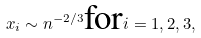Convert formula to latex. <formula><loc_0><loc_0><loc_500><loc_500>x _ { i } \sim n ^ { - 2 / 3 } \text {for} i = 1 , 2 , 3 ,</formula> 